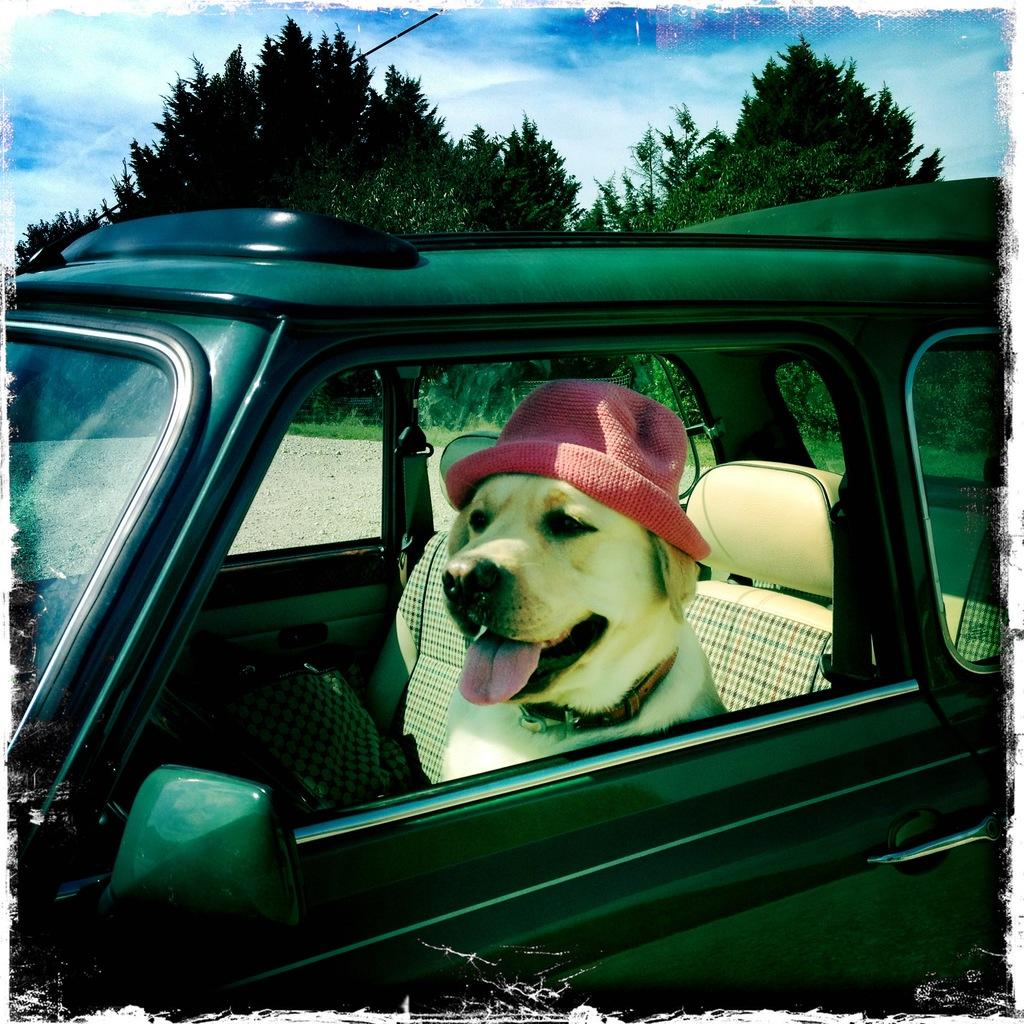What animal is present in the image? There is a dog in the image. What is the dog wearing? The dog is wearing a pink hat. Where is the dog located in the image? The dog is sitting in a black car. What degree does the hen have in the image? There is no hen present in the image, so it cannot have a degree. 